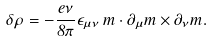Convert formula to latex. <formula><loc_0><loc_0><loc_500><loc_500>\delta \rho = - \frac { e \nu } { 8 \pi } \epsilon _ { \mu \nu } \, { m } \cdot \partial _ { \mu } { m } \times \partial _ { \nu } { m } .</formula> 